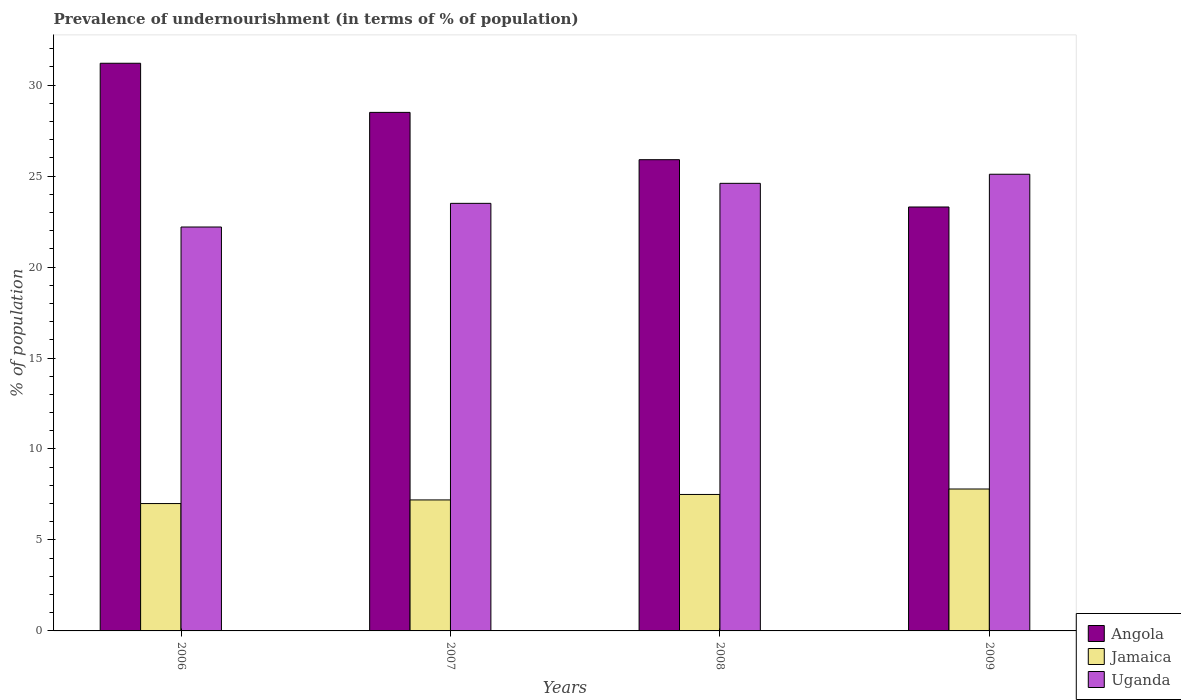How many different coloured bars are there?
Give a very brief answer. 3. How many groups of bars are there?
Your answer should be compact. 4. Are the number of bars per tick equal to the number of legend labels?
Provide a short and direct response. Yes. Are the number of bars on each tick of the X-axis equal?
Your answer should be very brief. Yes. In how many cases, is the number of bars for a given year not equal to the number of legend labels?
Keep it short and to the point. 0. Across all years, what is the maximum percentage of undernourished population in Angola?
Keep it short and to the point. 31.2. Across all years, what is the minimum percentage of undernourished population in Jamaica?
Make the answer very short. 7. In which year was the percentage of undernourished population in Angola maximum?
Make the answer very short. 2006. What is the total percentage of undernourished population in Uganda in the graph?
Ensure brevity in your answer.  95.4. What is the difference between the percentage of undernourished population in Jamaica in 2006 and that in 2007?
Your answer should be very brief. -0.2. What is the difference between the percentage of undernourished population in Uganda in 2009 and the percentage of undernourished population in Angola in 2006?
Offer a terse response. -6.1. What is the average percentage of undernourished population in Uganda per year?
Provide a short and direct response. 23.85. In the year 2007, what is the difference between the percentage of undernourished population in Angola and percentage of undernourished population in Jamaica?
Provide a short and direct response. 21.3. What is the ratio of the percentage of undernourished population in Uganda in 2008 to that in 2009?
Your answer should be very brief. 0.98. Is the difference between the percentage of undernourished population in Angola in 2007 and 2008 greater than the difference between the percentage of undernourished population in Jamaica in 2007 and 2008?
Provide a succinct answer. Yes. What is the difference between the highest and the lowest percentage of undernourished population in Uganda?
Make the answer very short. 2.9. In how many years, is the percentage of undernourished population in Angola greater than the average percentage of undernourished population in Angola taken over all years?
Provide a short and direct response. 2. What does the 2nd bar from the left in 2006 represents?
Your answer should be very brief. Jamaica. What does the 3rd bar from the right in 2007 represents?
Provide a short and direct response. Angola. How many bars are there?
Provide a short and direct response. 12. Are all the bars in the graph horizontal?
Provide a succinct answer. No. What is the difference between two consecutive major ticks on the Y-axis?
Make the answer very short. 5. Does the graph contain grids?
Your response must be concise. No. How are the legend labels stacked?
Your response must be concise. Vertical. What is the title of the graph?
Offer a terse response. Prevalence of undernourishment (in terms of % of population). Does "Germany" appear as one of the legend labels in the graph?
Provide a short and direct response. No. What is the label or title of the Y-axis?
Give a very brief answer. % of population. What is the % of population in Angola in 2006?
Keep it short and to the point. 31.2. What is the % of population in Uganda in 2006?
Make the answer very short. 22.2. What is the % of population in Jamaica in 2007?
Offer a very short reply. 7.2. What is the % of population of Uganda in 2007?
Your answer should be very brief. 23.5. What is the % of population of Angola in 2008?
Ensure brevity in your answer.  25.9. What is the % of population in Jamaica in 2008?
Your answer should be compact. 7.5. What is the % of population of Uganda in 2008?
Keep it short and to the point. 24.6. What is the % of population of Angola in 2009?
Make the answer very short. 23.3. What is the % of population of Uganda in 2009?
Ensure brevity in your answer.  25.1. Across all years, what is the maximum % of population in Angola?
Your answer should be compact. 31.2. Across all years, what is the maximum % of population of Jamaica?
Ensure brevity in your answer.  7.8. Across all years, what is the maximum % of population of Uganda?
Offer a very short reply. 25.1. Across all years, what is the minimum % of population in Angola?
Provide a short and direct response. 23.3. Across all years, what is the minimum % of population in Uganda?
Your answer should be compact. 22.2. What is the total % of population of Angola in the graph?
Ensure brevity in your answer.  108.9. What is the total % of population in Jamaica in the graph?
Ensure brevity in your answer.  29.5. What is the total % of population of Uganda in the graph?
Ensure brevity in your answer.  95.4. What is the difference between the % of population in Jamaica in 2006 and that in 2007?
Make the answer very short. -0.2. What is the difference between the % of population in Angola in 2006 and that in 2008?
Give a very brief answer. 5.3. What is the difference between the % of population of Jamaica in 2006 and that in 2008?
Ensure brevity in your answer.  -0.5. What is the difference between the % of population in Angola in 2006 and that in 2009?
Give a very brief answer. 7.9. What is the difference between the % of population of Jamaica in 2006 and that in 2009?
Make the answer very short. -0.8. What is the difference between the % of population of Uganda in 2006 and that in 2009?
Give a very brief answer. -2.9. What is the difference between the % of population in Jamaica in 2007 and that in 2008?
Offer a terse response. -0.3. What is the difference between the % of population in Angola in 2007 and that in 2009?
Ensure brevity in your answer.  5.2. What is the difference between the % of population in Jamaica in 2006 and the % of population in Uganda in 2007?
Your answer should be very brief. -16.5. What is the difference between the % of population of Angola in 2006 and the % of population of Jamaica in 2008?
Your response must be concise. 23.7. What is the difference between the % of population in Angola in 2006 and the % of population in Uganda in 2008?
Provide a short and direct response. 6.6. What is the difference between the % of population of Jamaica in 2006 and the % of population of Uganda in 2008?
Provide a succinct answer. -17.6. What is the difference between the % of population in Angola in 2006 and the % of population in Jamaica in 2009?
Offer a very short reply. 23.4. What is the difference between the % of population in Angola in 2006 and the % of population in Uganda in 2009?
Your answer should be very brief. 6.1. What is the difference between the % of population in Jamaica in 2006 and the % of population in Uganda in 2009?
Keep it short and to the point. -18.1. What is the difference between the % of population in Angola in 2007 and the % of population in Jamaica in 2008?
Offer a very short reply. 21. What is the difference between the % of population of Jamaica in 2007 and the % of population of Uganda in 2008?
Keep it short and to the point. -17.4. What is the difference between the % of population of Angola in 2007 and the % of population of Jamaica in 2009?
Your response must be concise. 20.7. What is the difference between the % of population of Angola in 2007 and the % of population of Uganda in 2009?
Offer a very short reply. 3.4. What is the difference between the % of population in Jamaica in 2007 and the % of population in Uganda in 2009?
Give a very brief answer. -17.9. What is the difference between the % of population of Angola in 2008 and the % of population of Jamaica in 2009?
Your answer should be compact. 18.1. What is the difference between the % of population in Angola in 2008 and the % of population in Uganda in 2009?
Provide a succinct answer. 0.8. What is the difference between the % of population in Jamaica in 2008 and the % of population in Uganda in 2009?
Your response must be concise. -17.6. What is the average % of population in Angola per year?
Make the answer very short. 27.23. What is the average % of population of Jamaica per year?
Make the answer very short. 7.38. What is the average % of population of Uganda per year?
Your answer should be compact. 23.85. In the year 2006, what is the difference between the % of population in Angola and % of population in Jamaica?
Your answer should be compact. 24.2. In the year 2006, what is the difference between the % of population in Jamaica and % of population in Uganda?
Provide a short and direct response. -15.2. In the year 2007, what is the difference between the % of population in Angola and % of population in Jamaica?
Your answer should be very brief. 21.3. In the year 2007, what is the difference between the % of population of Angola and % of population of Uganda?
Keep it short and to the point. 5. In the year 2007, what is the difference between the % of population of Jamaica and % of population of Uganda?
Offer a very short reply. -16.3. In the year 2008, what is the difference between the % of population in Jamaica and % of population in Uganda?
Give a very brief answer. -17.1. In the year 2009, what is the difference between the % of population in Angola and % of population in Uganda?
Offer a terse response. -1.8. In the year 2009, what is the difference between the % of population in Jamaica and % of population in Uganda?
Offer a very short reply. -17.3. What is the ratio of the % of population in Angola in 2006 to that in 2007?
Give a very brief answer. 1.09. What is the ratio of the % of population of Jamaica in 2006 to that in 2007?
Your answer should be very brief. 0.97. What is the ratio of the % of population of Uganda in 2006 to that in 2007?
Ensure brevity in your answer.  0.94. What is the ratio of the % of population of Angola in 2006 to that in 2008?
Ensure brevity in your answer.  1.2. What is the ratio of the % of population in Jamaica in 2006 to that in 2008?
Your answer should be compact. 0.93. What is the ratio of the % of population in Uganda in 2006 to that in 2008?
Your answer should be compact. 0.9. What is the ratio of the % of population of Angola in 2006 to that in 2009?
Offer a terse response. 1.34. What is the ratio of the % of population of Jamaica in 2006 to that in 2009?
Keep it short and to the point. 0.9. What is the ratio of the % of population in Uganda in 2006 to that in 2009?
Your answer should be very brief. 0.88. What is the ratio of the % of population in Angola in 2007 to that in 2008?
Provide a short and direct response. 1.1. What is the ratio of the % of population in Jamaica in 2007 to that in 2008?
Your answer should be compact. 0.96. What is the ratio of the % of population of Uganda in 2007 to that in 2008?
Your answer should be very brief. 0.96. What is the ratio of the % of population of Angola in 2007 to that in 2009?
Your response must be concise. 1.22. What is the ratio of the % of population in Uganda in 2007 to that in 2009?
Your answer should be very brief. 0.94. What is the ratio of the % of population in Angola in 2008 to that in 2009?
Offer a terse response. 1.11. What is the ratio of the % of population in Jamaica in 2008 to that in 2009?
Ensure brevity in your answer.  0.96. What is the ratio of the % of population of Uganda in 2008 to that in 2009?
Provide a succinct answer. 0.98. What is the difference between the highest and the second highest % of population in Jamaica?
Provide a short and direct response. 0.3. What is the difference between the highest and the lowest % of population of Angola?
Offer a terse response. 7.9. What is the difference between the highest and the lowest % of population of Uganda?
Make the answer very short. 2.9. 